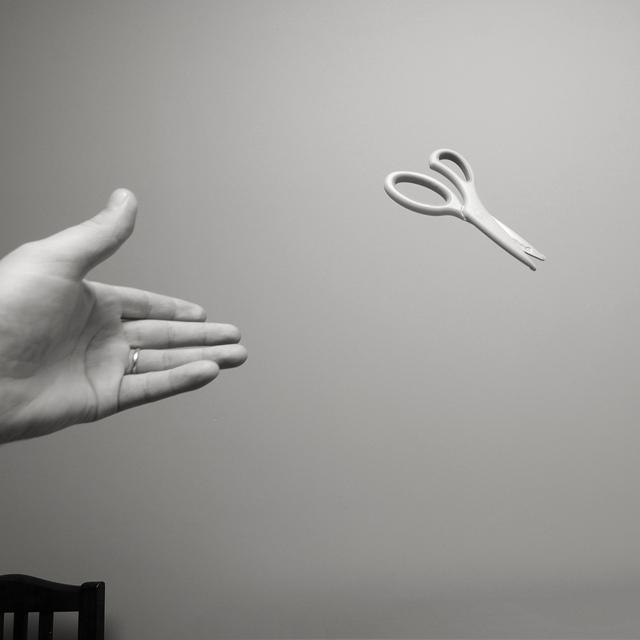What are the items sitting on?
Quick response, please. Nothing. What is the hand about to catch?
Write a very short answer. Scissors. Where is the ring?
Short answer required. On ring finger. What color is the scissors?
Keep it brief. White. What is thrown?
Short answer required. Scissors. Are the scissors open or closed?
Be succinct. Closed. What color are the handles?
Concise answer only. White. What is in the bottom left side of the photo?
Write a very short answer. Chair. 